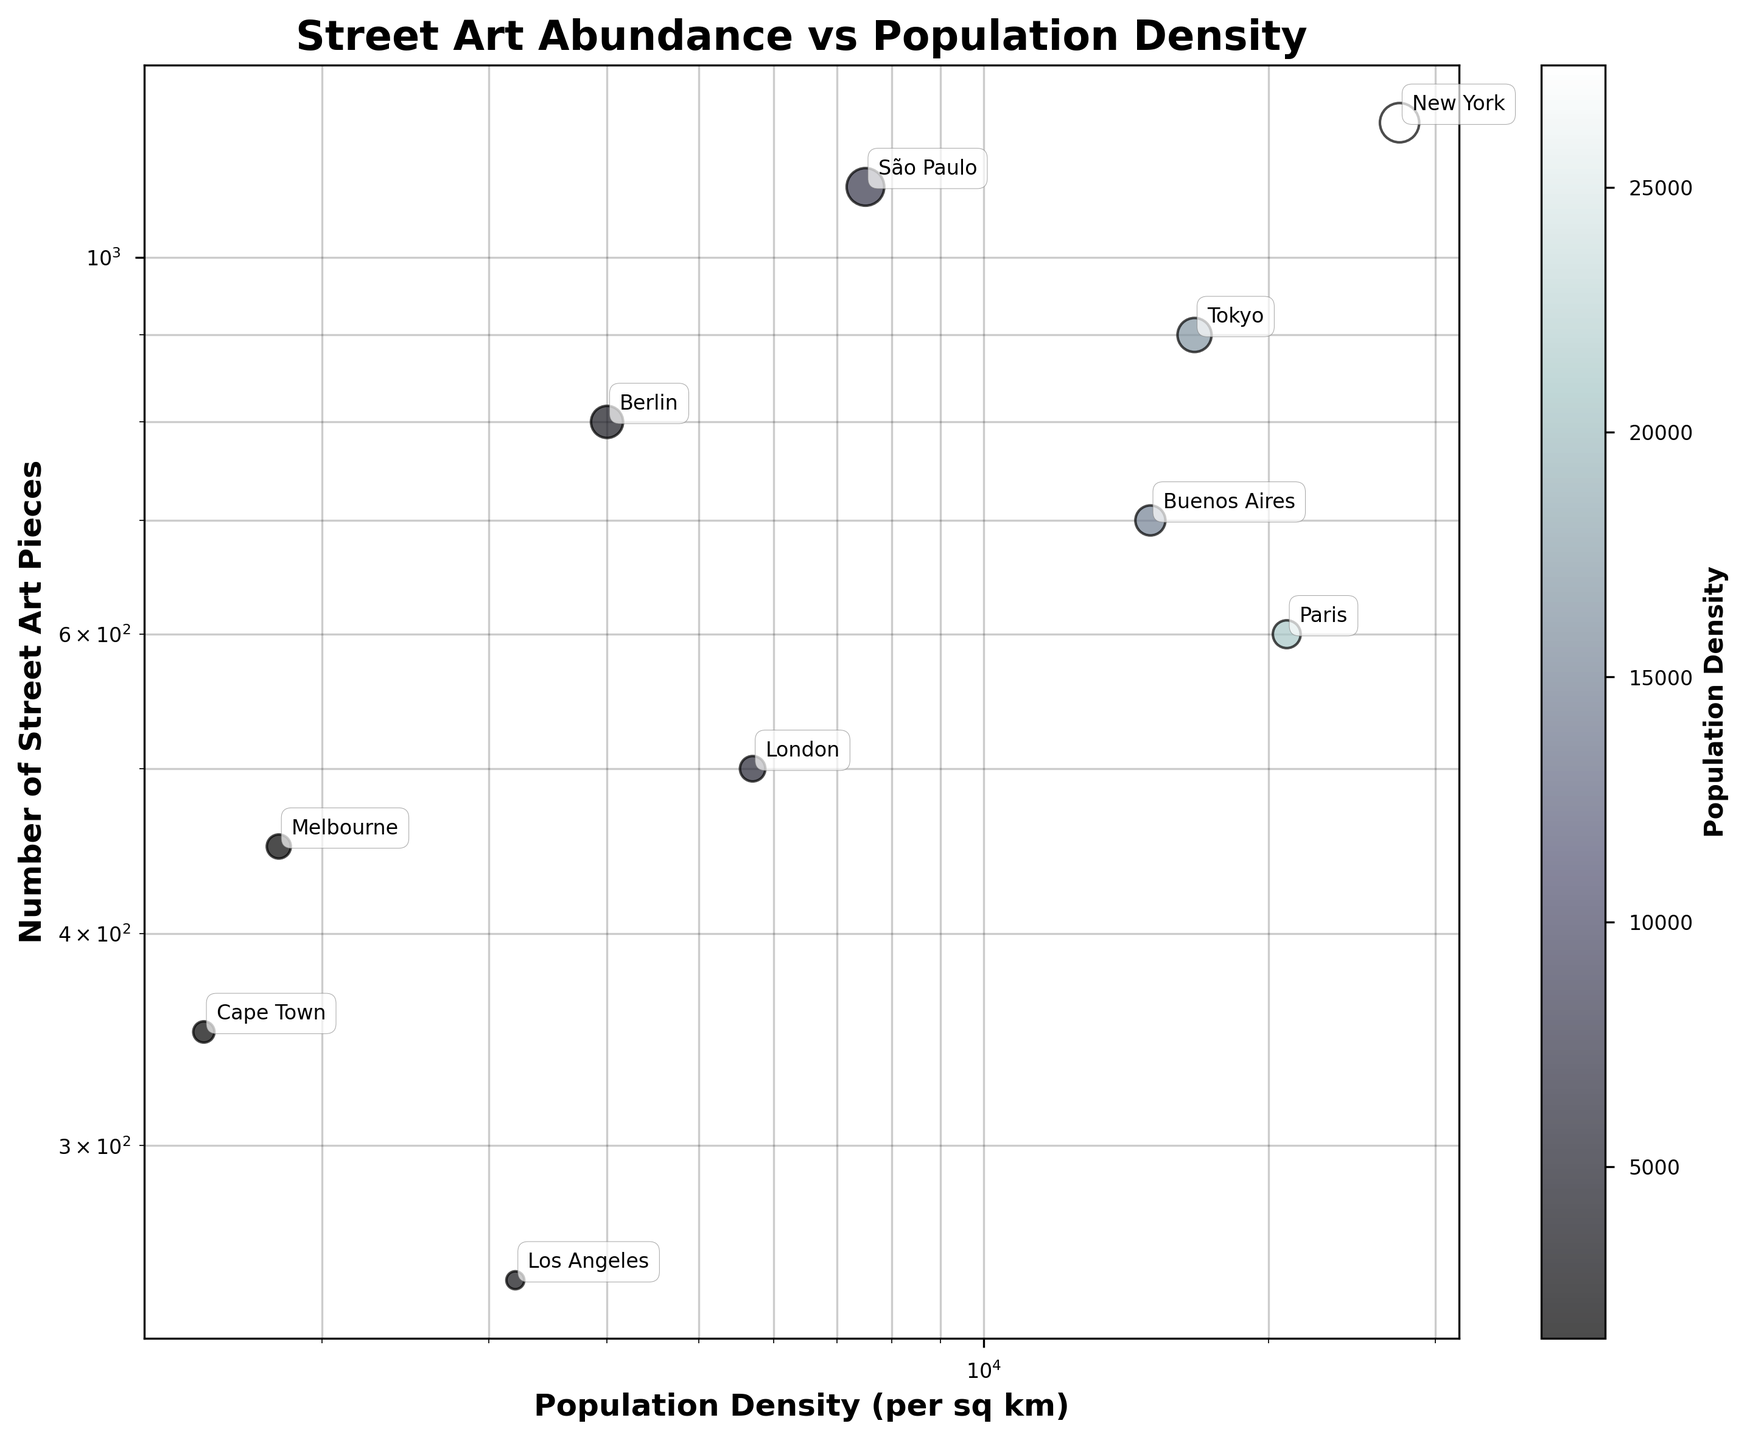what is the title of the figure? The title is usually found at the top of the figure. In this case, the title is clearly displayed above the plot area.
Answer: Street Art Abundance vs Population Density How many data points are presented in the figure? Count the number of distinct cities (data points) that are visible in the scatter plot. Each city corresponds to one data point.
Answer: 10 Which city has the highest population density? Look at the x-axis (log scale) to identify the highest value and locate the corresponding city labeled near that point.
Answer: New York What is the relationship between population density and the number of street art pieces for New York vs. Berlin? Compare the positions of New York and Berlin on both the x-axis (population density) and y-axis (street art pieces). New York has a much higher population density and also a higher number of street art pieces compared to Berlin.
Answer: New York has higher values for both Which city has the fewest number of street art pieces? Look at the y-axis (log scale) to identify the lowest value and locate the corresponding city labeled near that point.
Answer: Los Angeles What is the median number of street art pieces among all the cities? Organize the cities by the number of street art pieces, and find the middle value, given there are 10 cities. The median will be the average of the 5th and 6th values when sorted in ascending order.
Answer: 650 How does the street art piece count in Tokyo compare to Melbourne? Find Tokyo and Melbourne on the scatter plot and compare their positions on the y-axis (number of street art pieces). Tokyo has more street art pieces than Melbourne.
Answer: Tokyo has more Which city with a population density above 10,000 per sq km has the least number of street art pieces? Identify cities with a population density above 10,000 per sq km on the x-axis and among those select the one with the lowest y-axis value.
Answer: Paris How does the relationship pattern between population density and street art pieces hold on a log-log scale? Consider the overall trend of the data points on a log-log scale, whether it shows any correlation and what type (positive, negative, none). Higher density often corresponds with more street art pieces, showing a positive correlation.
Answer: Positive correlation Is there any city that lies significantly off the common trend or pattern? Look for a city that visually appears far from the line or curve fitting the other cities. São Paulo, which has significantly more street arts compared to other cities with similar or higher population densities.
Answer: São Paulo 